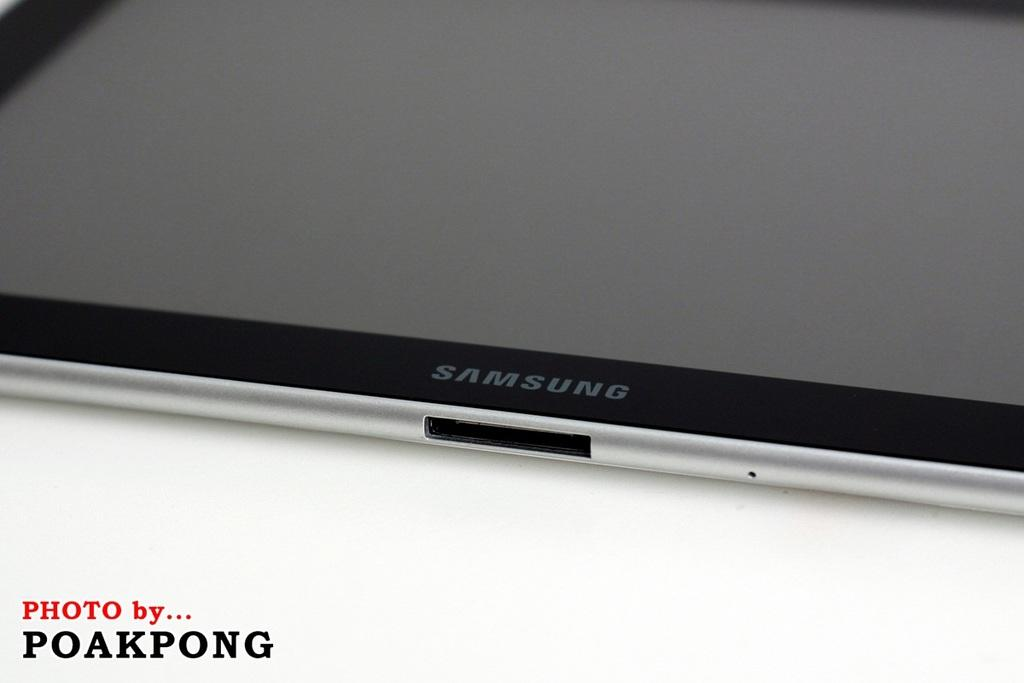<image>
Give a short and clear explanation of the subsequent image. A tablet that says Samsung is on a white surface. 